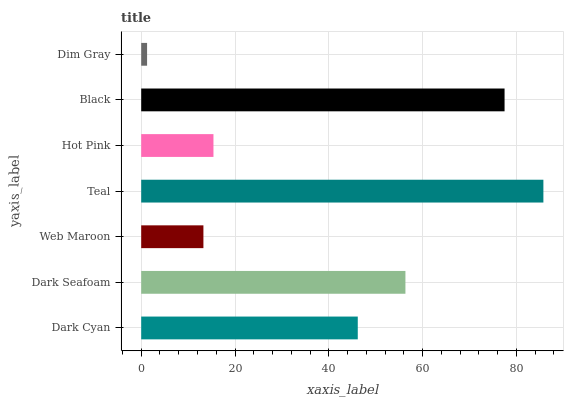Is Dim Gray the minimum?
Answer yes or no. Yes. Is Teal the maximum?
Answer yes or no. Yes. Is Dark Seafoam the minimum?
Answer yes or no. No. Is Dark Seafoam the maximum?
Answer yes or no. No. Is Dark Seafoam greater than Dark Cyan?
Answer yes or no. Yes. Is Dark Cyan less than Dark Seafoam?
Answer yes or no. Yes. Is Dark Cyan greater than Dark Seafoam?
Answer yes or no. No. Is Dark Seafoam less than Dark Cyan?
Answer yes or no. No. Is Dark Cyan the high median?
Answer yes or no. Yes. Is Dark Cyan the low median?
Answer yes or no. Yes. Is Web Maroon the high median?
Answer yes or no. No. Is Web Maroon the low median?
Answer yes or no. No. 